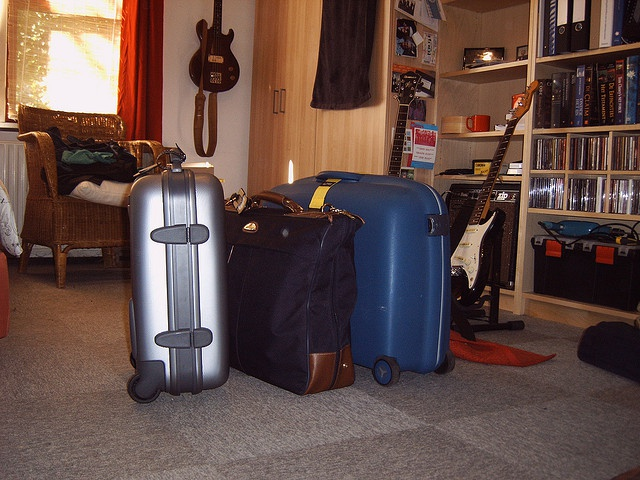Describe the objects in this image and their specific colors. I can see suitcase in lavender, black, maroon, navy, and brown tones, suitcase in lavender, gray, black, and darkgray tones, suitcase in lavender, navy, black, darkblue, and gray tones, chair in lavender, black, maroon, and gray tones, and book in lavender, black, maroon, and gray tones in this image. 